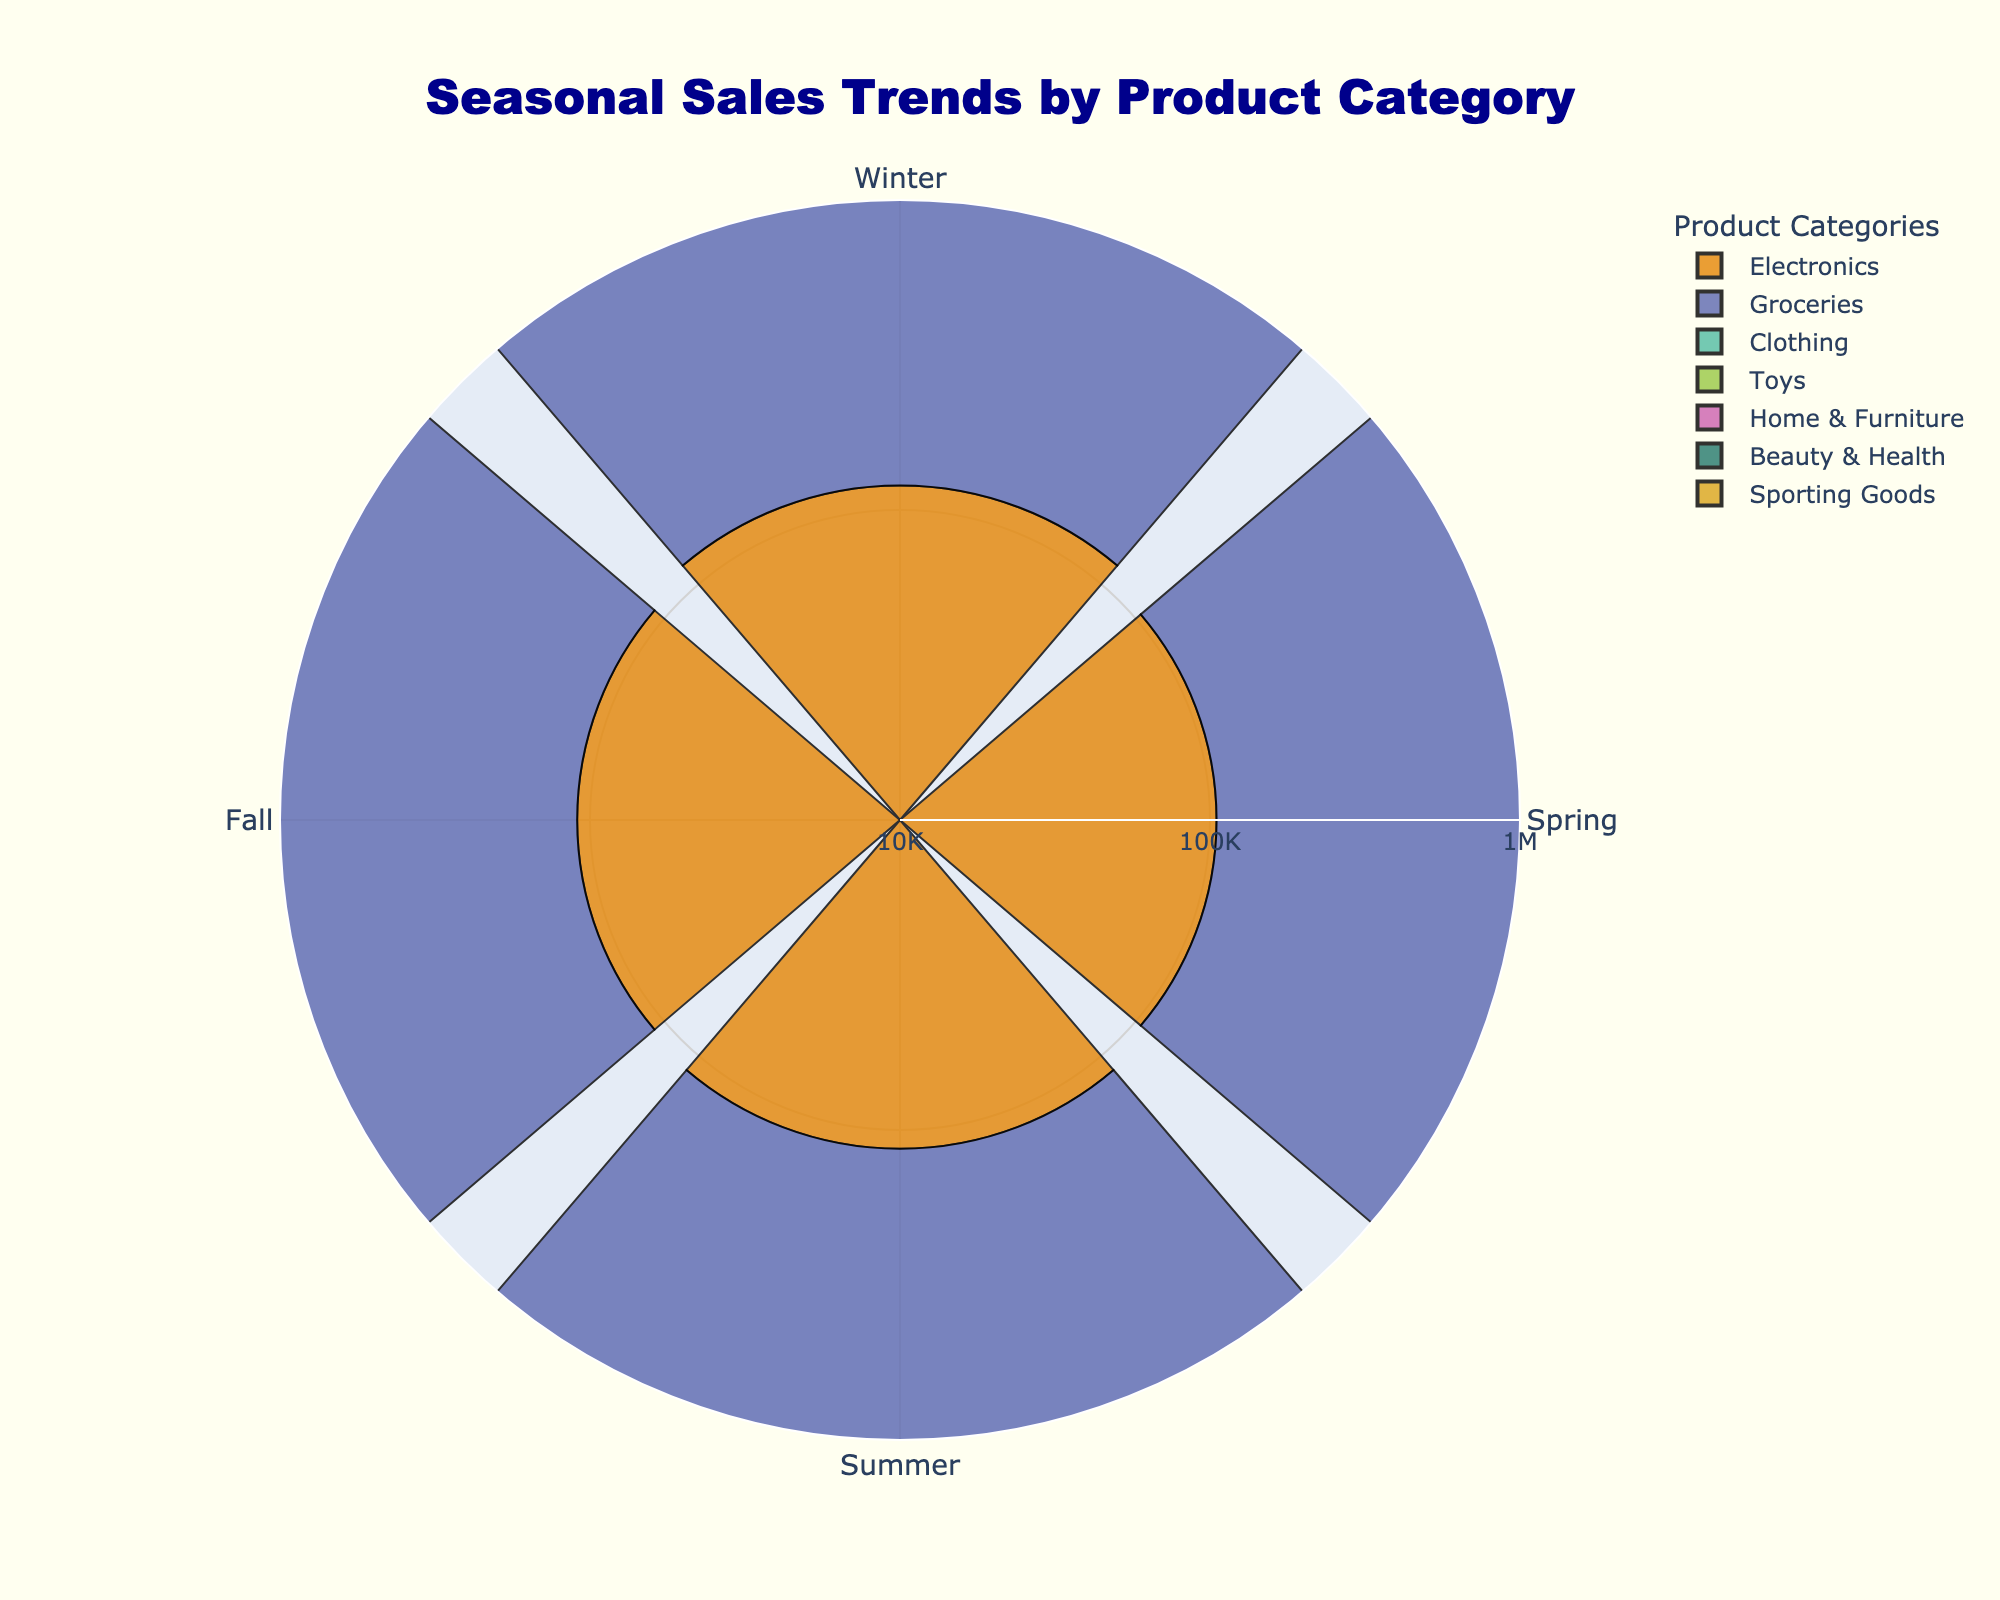Which product category had the highest sales in Winter? Looking at the bars in the winter section, identify the category with the longest bar.
Answer: Electronics Which season had the lowest sales for the category "Toys"? Check the four bars for the Toys category and find the one with the shortest length, which corresponds to the lowest sales.
Answer: Spring What is the general trend for Clothing sales across all seasons? Observe the bars for Clothing across Winter, Spring, Summer, and Fall to identify whether sales are increasing, decreasing, or fluctuating.
Answer: Fluctuating How do Electronics sales in Summer compare to Winter? Compare the lengths of the Electronics bars in Summer and Winter to see which is longer.
Answer: Lower in Summer On average, do Groceries have higher sales than Sporting Goods throughout the seasons? Calculate the average sales for both categories by summing their seasonal sales values and dividing by 4, then compare these averages.
Answer: Yes Which season shows similar sales figures for both Beauty & Health and Home & Furniture? Identify the seasons with bars of similar lengths for both Beauty & Health and Home & Furniture.
Answer: Spring How do the log-scaled sales values for Groceries in Fall and Summer compare? Compare the radial lengths for Groceries in Fall and Summer and see which is longer.
Answer: Fall is slightly higher Identify the season with the lowest overall sales across all categories. Look for the season with the shortest bars overall when considered across all categories.
Answer: Winter (Sporting Goods) What is the median sales value for the Home & Furniture category? Arrange the sales values of Home & Furniture (100000, 115000, 110000, 105000) in ascending order and find the middle value or the average of the two middle values.
Answer: 107500 